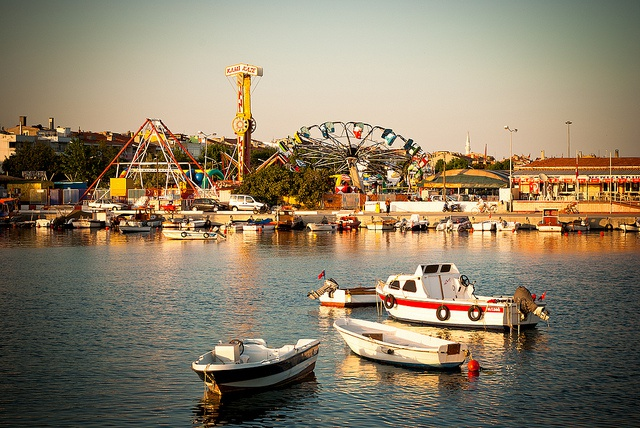Describe the objects in this image and their specific colors. I can see boat in gray, ivory, black, darkgray, and tan tones, boat in gray, black, darkgray, and beige tones, boat in gray, beige, tan, and black tones, boat in gray, black, khaki, maroon, and tan tones, and boat in gray, ivory, darkgray, black, and maroon tones in this image. 